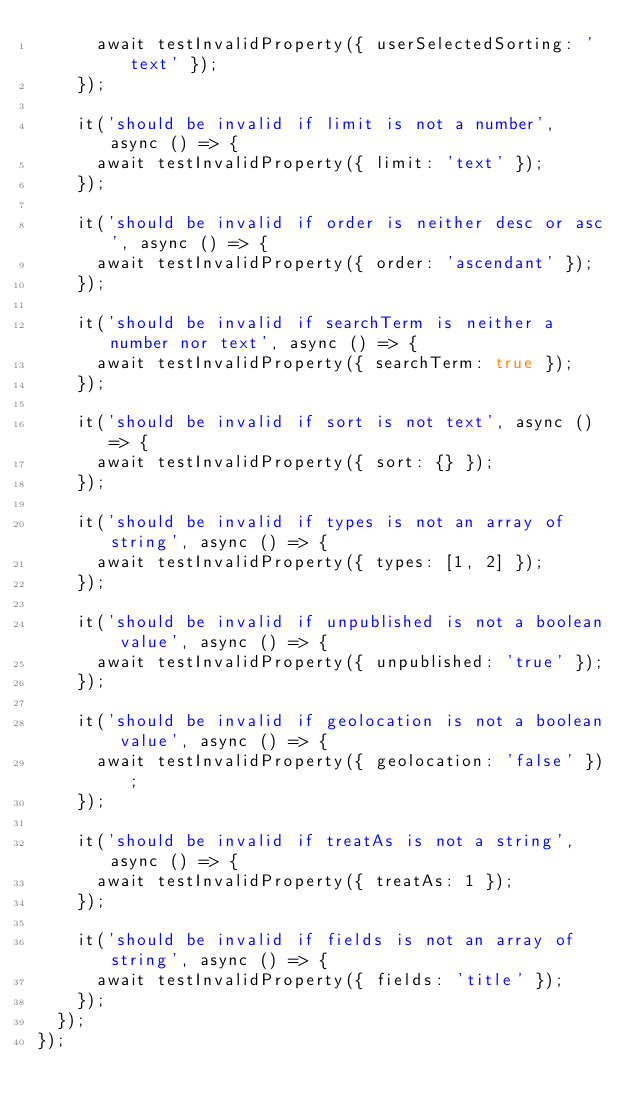Convert code to text. <code><loc_0><loc_0><loc_500><loc_500><_TypeScript_>      await testInvalidProperty({ userSelectedSorting: 'text' });
    });

    it('should be invalid if limit is not a number', async () => {
      await testInvalidProperty({ limit: 'text' });
    });

    it('should be invalid if order is neither desc or asc', async () => {
      await testInvalidProperty({ order: 'ascendant' });
    });

    it('should be invalid if searchTerm is neither a number nor text', async () => {
      await testInvalidProperty({ searchTerm: true });
    });

    it('should be invalid if sort is not text', async () => {
      await testInvalidProperty({ sort: {} });
    });

    it('should be invalid if types is not an array of string', async () => {
      await testInvalidProperty({ types: [1, 2] });
    });

    it('should be invalid if unpublished is not a boolean value', async () => {
      await testInvalidProperty({ unpublished: 'true' });
    });

    it('should be invalid if geolocation is not a boolean value', async () => {
      await testInvalidProperty({ geolocation: 'false' });
    });

    it('should be invalid if treatAs is not a string', async () => {
      await testInvalidProperty({ treatAs: 1 });
    });

    it('should be invalid if fields is not an array of string', async () => {
      await testInvalidProperty({ fields: 'title' });
    });
  });
});
</code> 